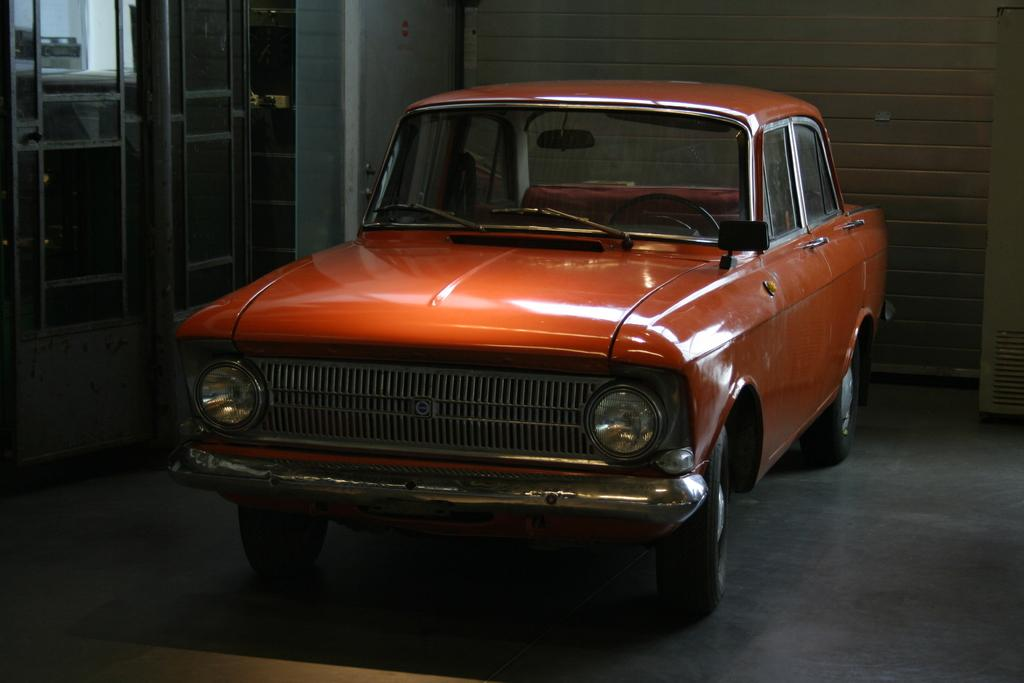What is the main subject in the front of the image? There is a vehicle in the front of the image. What can be seen in the background of the image? There is a pole and a wall in the background of the image. Are there any other objects visible in the background? Yes, there are objects in the background of the image. What color is the family's tongue in the image? There is no family or tongue present in the image. How many clocks can be seen on the wall in the image? There is no wall with clocks in the image; only a pole and other unspecified objects are visible in the background. 